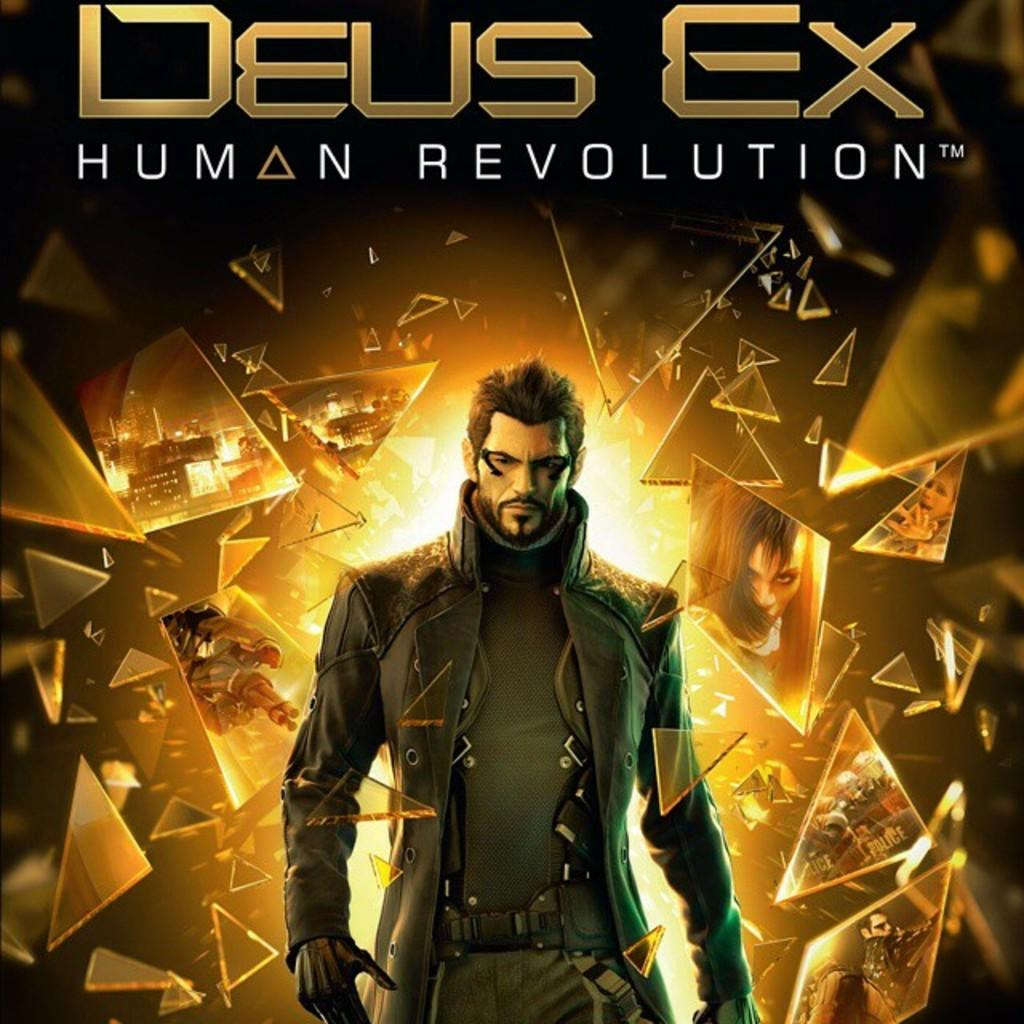<image>
Summarize the visual content of the image. Poster of a man walking through glass named "Deus Ex". 